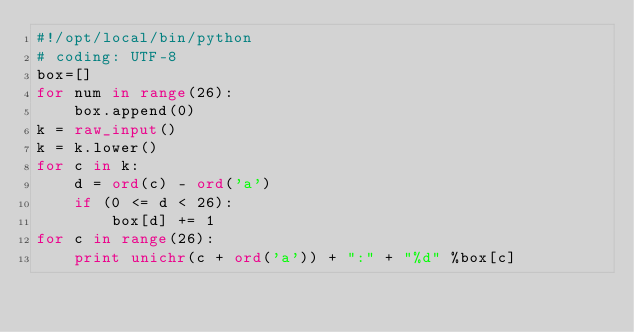Convert code to text. <code><loc_0><loc_0><loc_500><loc_500><_Python_>#!/opt/local/bin/python
# coding: UTF-8
box=[]
for num in range(26):
	box.append(0)
k = raw_input()
k = k.lower()
for c in k:
	d = ord(c) - ord('a')
	if (0 <= d < 26):
		box[d] += 1
for c in range(26):
	print unichr(c + ord('a')) + ":" + "%d" %box[c]</code> 